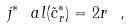Convert formula to latex. <formula><loc_0><loc_0><loc_500><loc_500>j ^ { * } \ a l ( \tilde { c } ^ { * } _ { r } ) = 2 r \ ,</formula> 